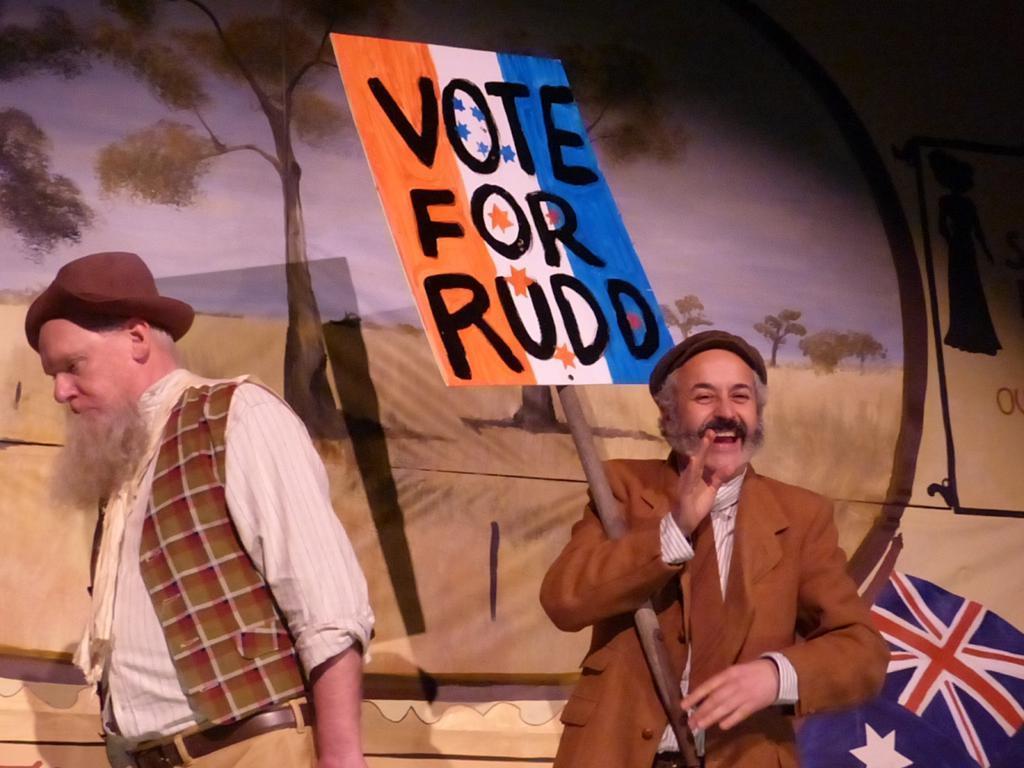How would you summarize this image in a sentence or two? In this image there are two people standing, one of them is smiling and holding a board with some text on it, behind them there is a painting on the wall. 